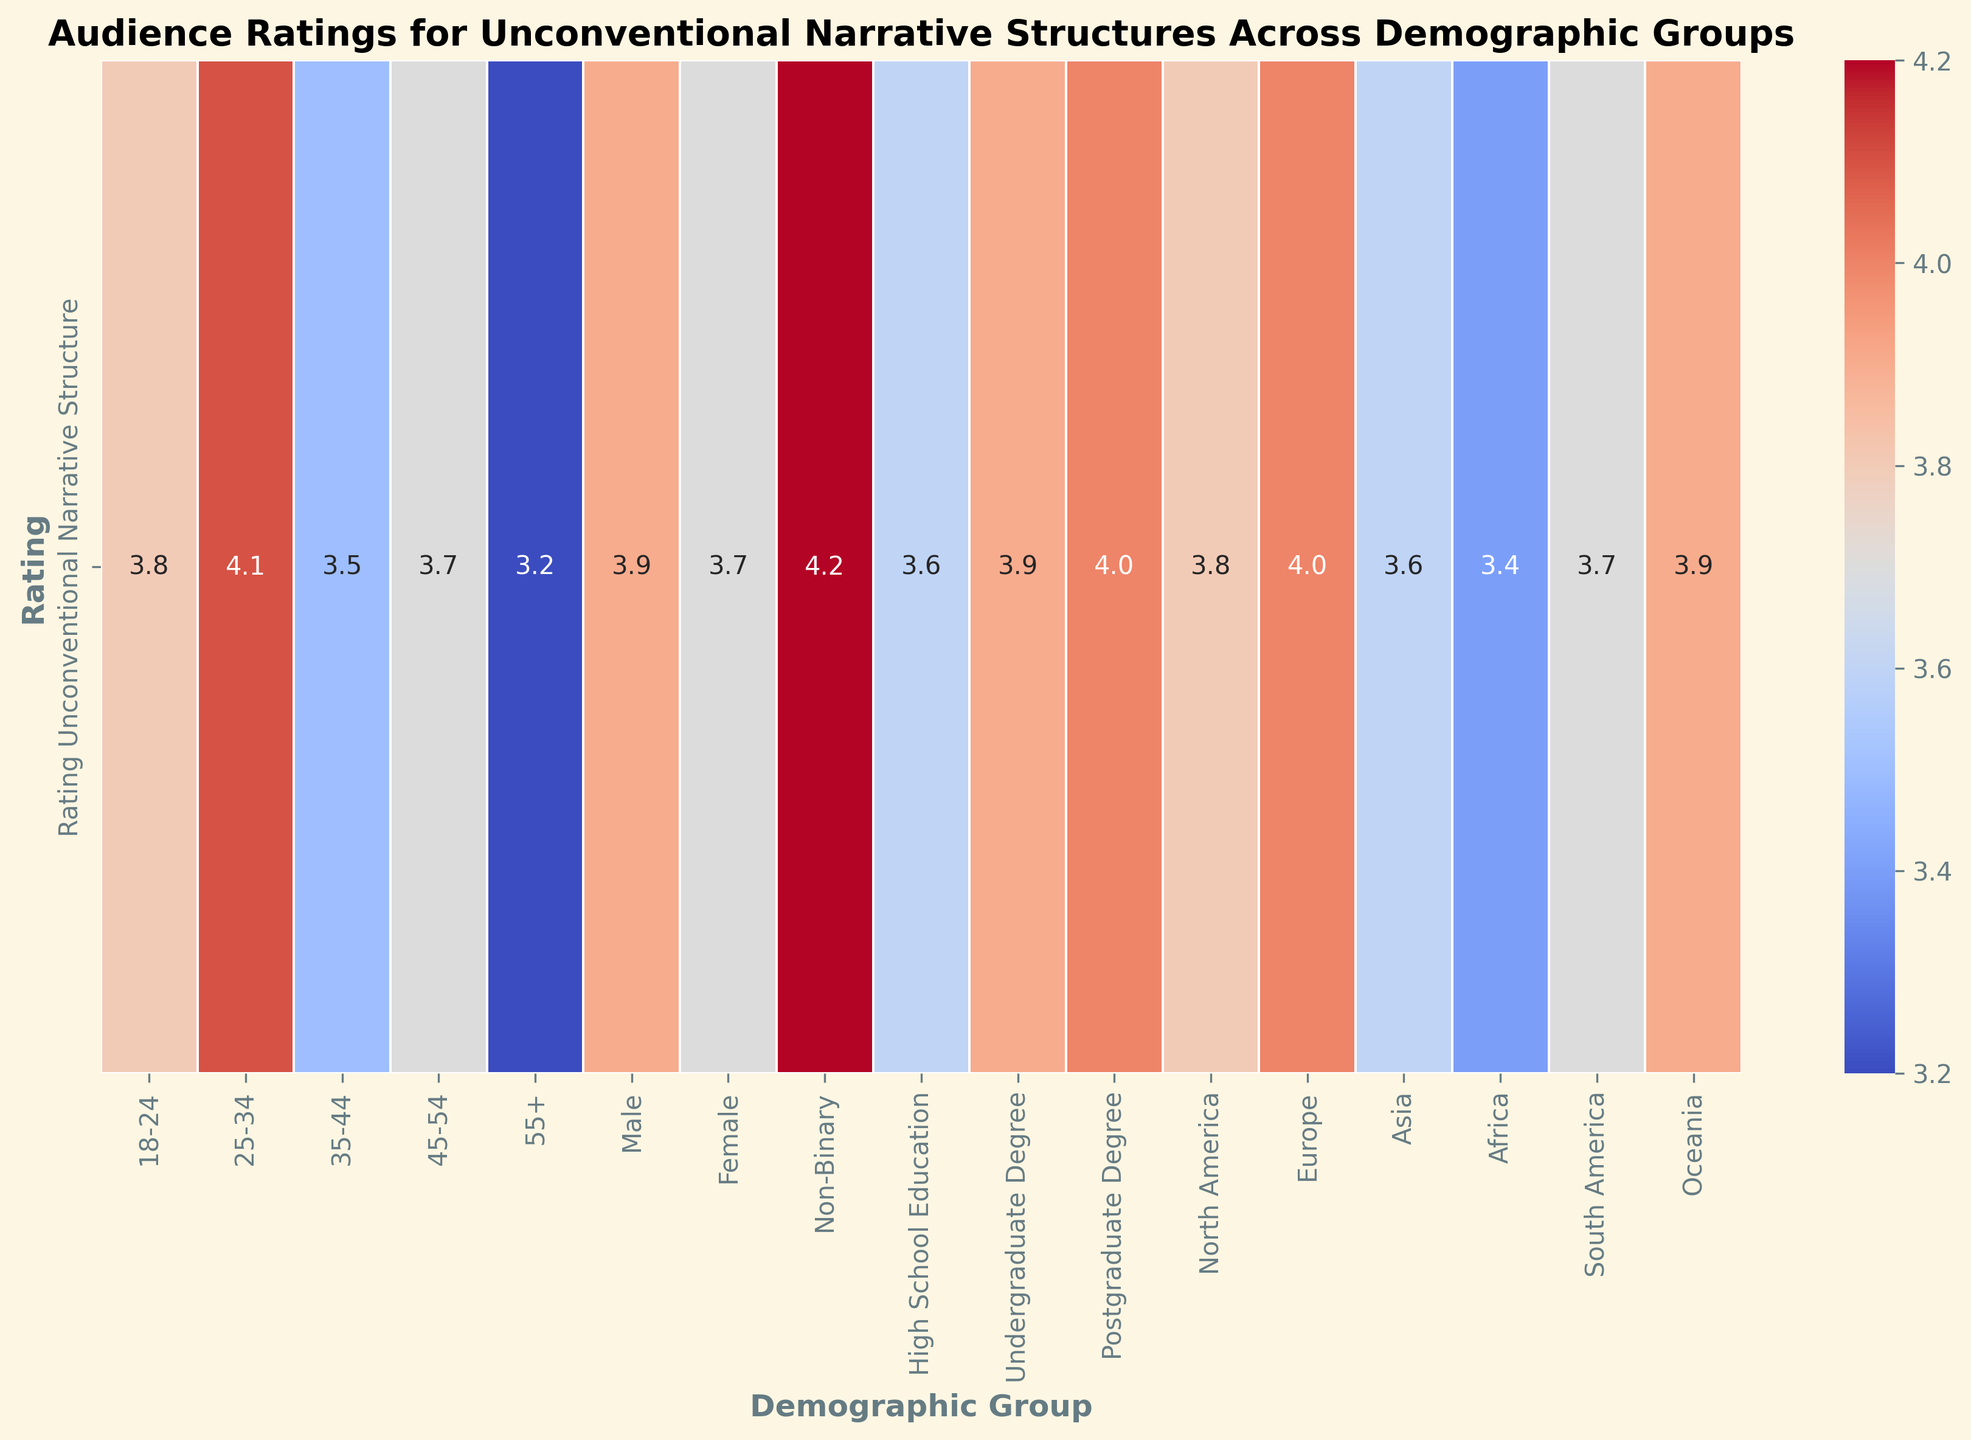Which demographic group rated unconventional narrative structures the highest? By examining the heatmap and looking for the cell with the highest numerical value, we identify the demographic group with the highest rating. The darkest red color will also help highlight this group.
Answer: Non-Binary How does the rating for unconventional narrative structures among 18-24 year-olds compare to that among 55+ year-olds? Locate the ratings for the 18-24 and 55+ age groups in the heatmap and compare the values directly.
Answer: Higher for 18-24 year-olds What is the difference in ratings for unconventional narrative structures between Europe and Africa? Find the rating values for both Europe and Africa and calculate their difference by subtracting the African rating from the European rating.
Answer: 0.6 Which two demographic groups have the most similar ratings for unconventional narrative structures? Scan the heatmap to identify the pairs of demographic groups with the closest rating values, looking for similar shades of color and numerical values.
Answer: 45-54 and North America What is the average rating for unconventional narrative structures across all demographic groups? Sum up all the rating values from the heatmap and divide by the total number of demographic groups to find the average. (Sum = 58.6, Number of groups = 16, so 58.6 / 16)
Answer: 3.7 Is there a noticeable trend in ratings among different education levels? Observe the numerical values and color shades across High School Education, Undergraduate Degree, and Postgraduate Degree to determine if ratings increase, decrease, or show another pattern.
Answer: Increase with higher education How does the rating for unconventional narrative structures in South America compare to the global average rating? Find the rating value for South America and compare it to the previously calculated average rating across all groups (3.7).
Answer: Equal to the average Which region has the lowest rating for unconventional narrative structures, and what is that rating? Identify the cell with the smallest numerical value and verify it visually with the associated color (likely the lightest color on the heatmap), then note the region name.
Answer: Africa, 3.4 What is the sum of ratings for unconventional narrative structures for male and female demographics combined? Locate the rating values for Male and Female, then add these two values together.
Answer: 7.6 Which age group has a rating closest to 4.0, and how does it compare visually to the 25-34 age group? Look at the ratings for all age groups to find the one closest to 4.0. Then, compare this group's value and color intensity to the 25-34 age group rating (4.1).
Answer: 25-34, very close 